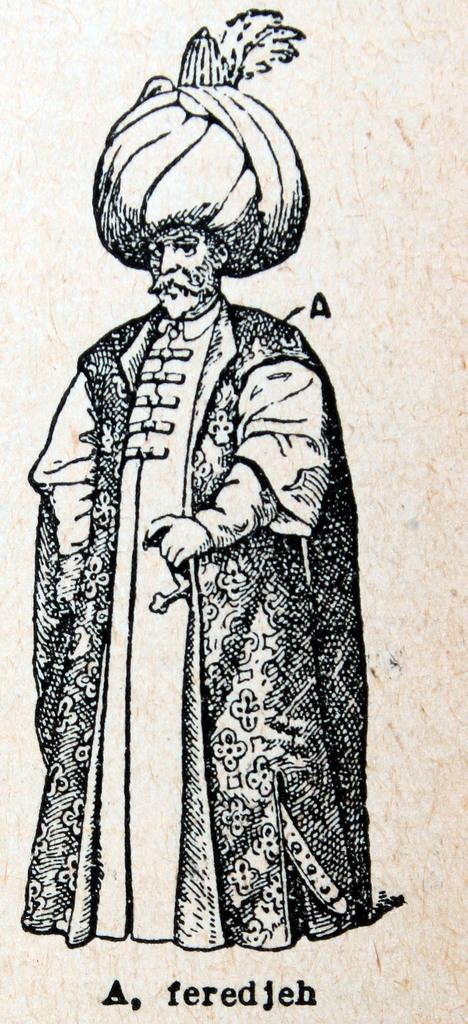What is depicted on the paper in the image? There is a printed picture of a man on a paper. What is the man in the picture wearing? The man is wearing a royal dress. What type of headwear does the man have in the picture? The man has a turban on his head. What type of insurance does the man in the picture have? There is no information about insurance in the image; it only shows a printed picture of a man wearing a royal dress and a turban. 